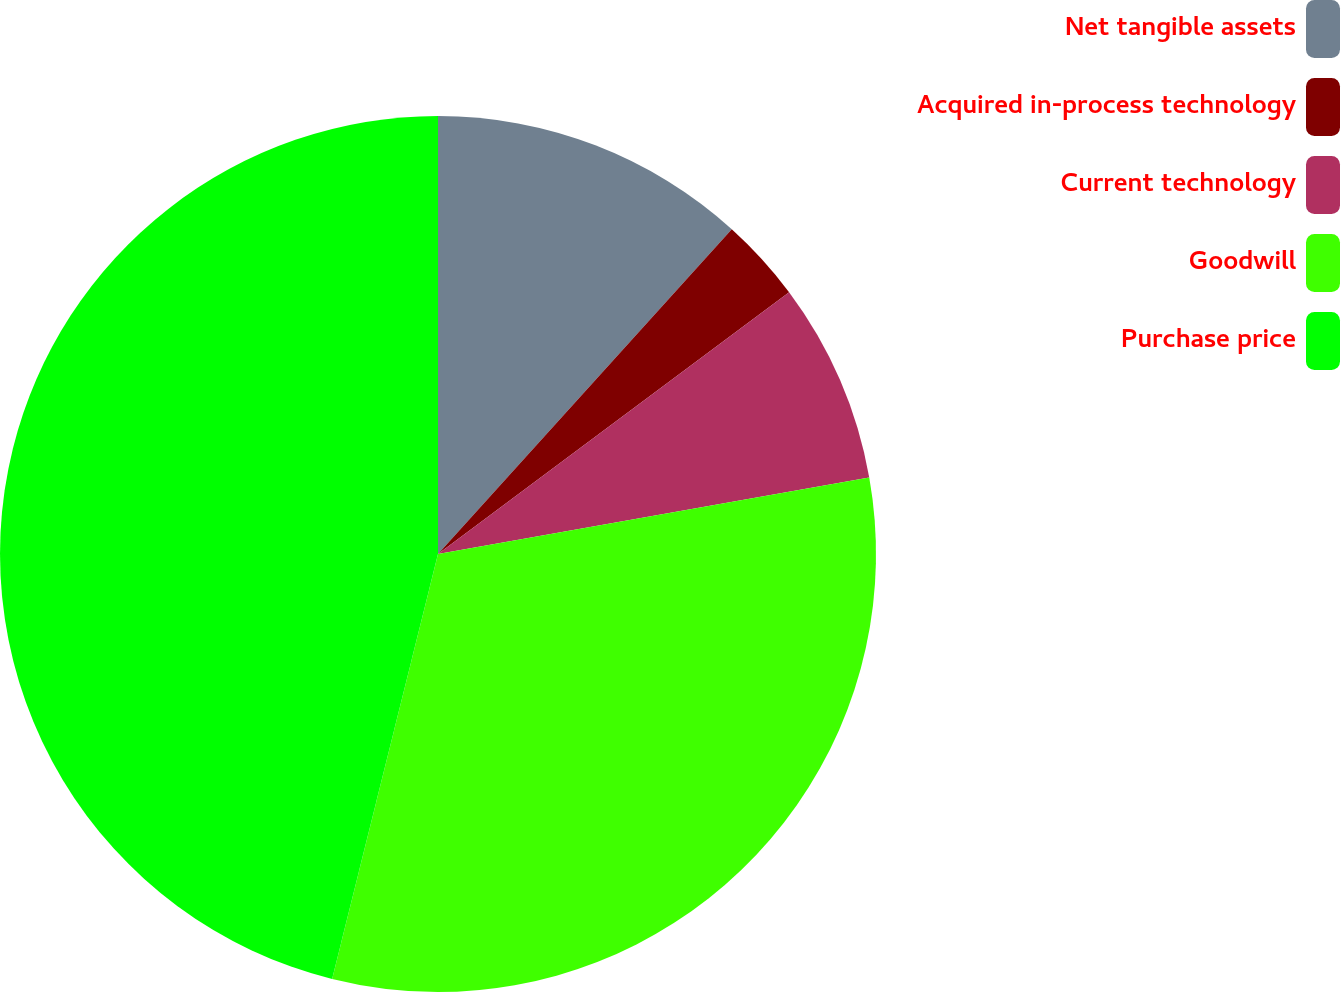<chart> <loc_0><loc_0><loc_500><loc_500><pie_chart><fcel>Net tangible assets<fcel>Acquired in-process technology<fcel>Current technology<fcel>Goodwill<fcel>Purchase price<nl><fcel>11.7%<fcel>3.1%<fcel>7.4%<fcel>31.68%<fcel>46.11%<nl></chart> 